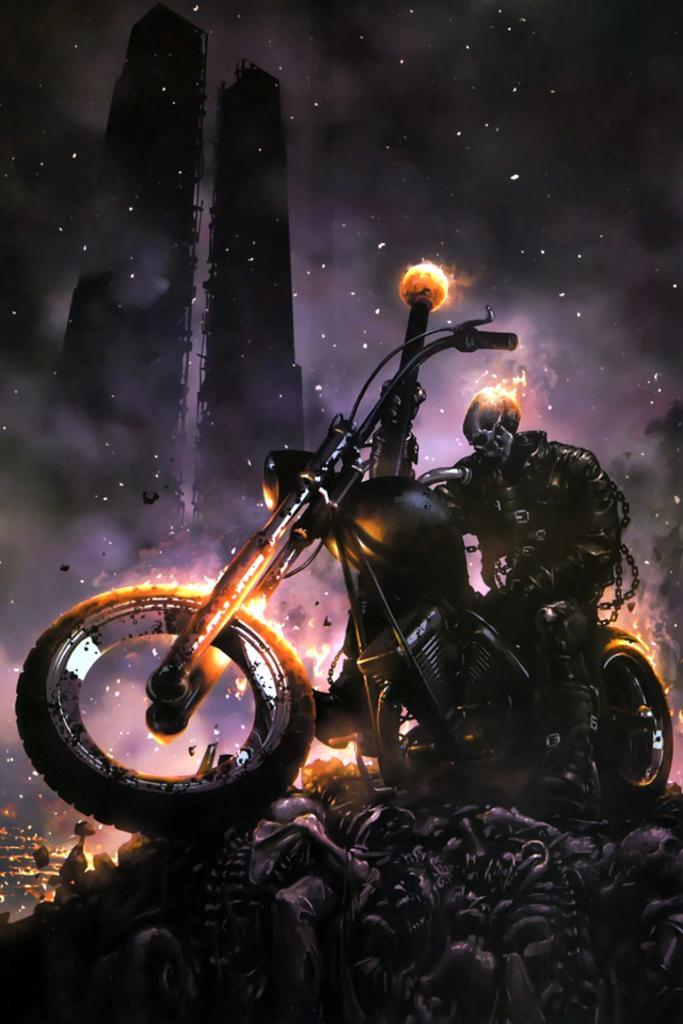Can you describe this image briefly? In this image we can see a person on bike and there is fire. In the background there are buildings and sky. At the bottom we can see some equipment. 